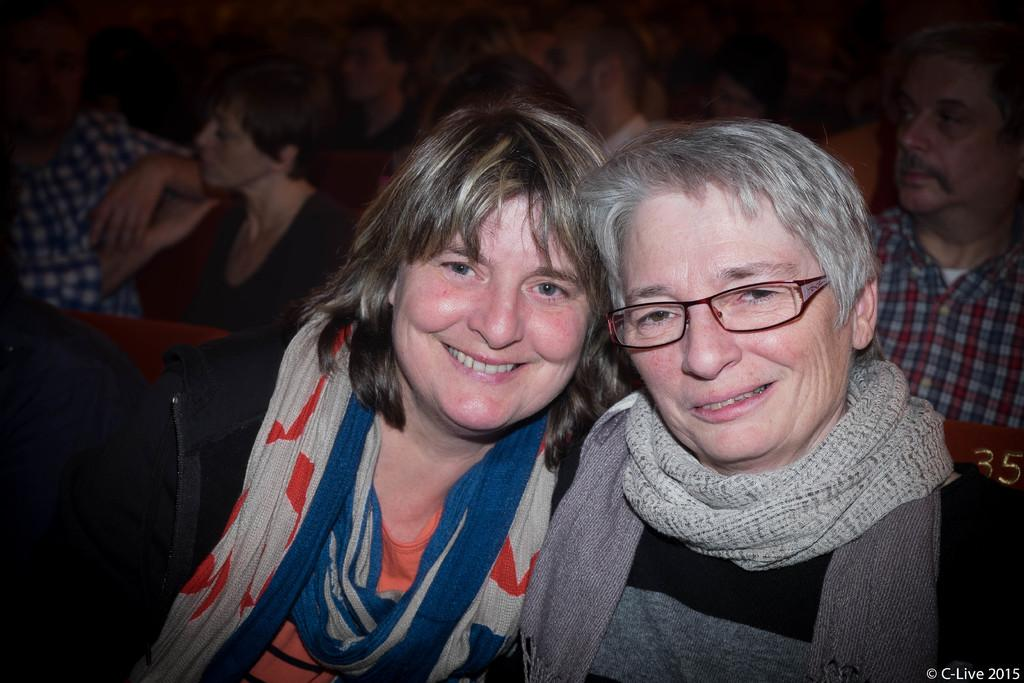How many people are in the image? There is a group of persons in the image. What can be seen in the image besides the people? There are seats in the image. Can you describe the expression of the person in the foreground? A person is smiling in the foreground. What is located in the bottom right corner of the image? There is some text in the bottom right corner of the image. What type of whip is being used by the person in the image? There is no whip present in the image. How many corks are visible in the image? There are no corks visible in the image. 